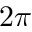Convert formula to latex. <formula><loc_0><loc_0><loc_500><loc_500>2 \pi</formula> 